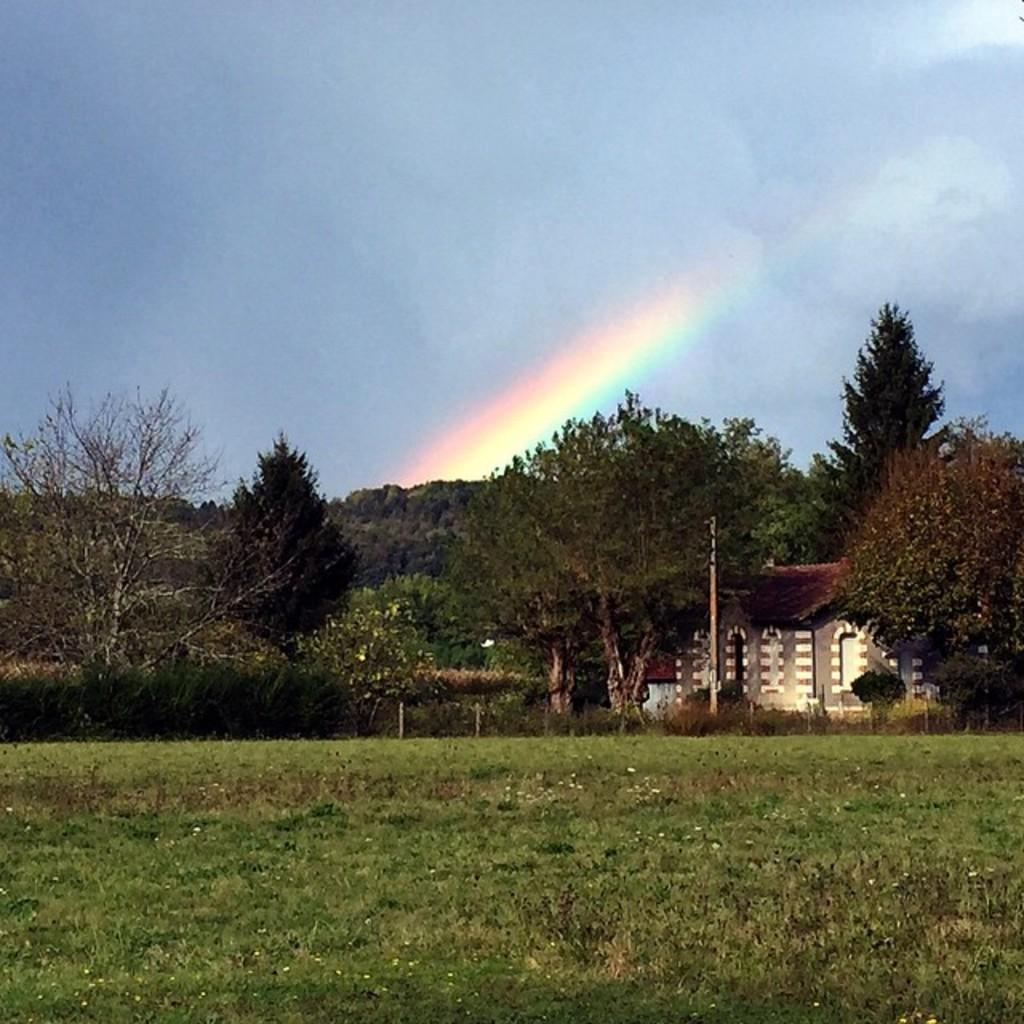What type of vegetation can be seen in the image? There are trees and plants in the image. What type of structure is present in the image? There is a building in the image. What type of terrain is visible in the image? There is grassy land in the image. What natural phenomenon can be seen in the background of the image? There is a rainbow visible in the background of the image. What else is visible in the background of the image? The sky is visible in the background of the image. Can you tell me how many teeth the person has in the image? There is no person present in the image, so it is not possible to determine the number of teeth. What type of channel is visible in the image? There is no channel present in the image; it features trees, plants, a building, grassy land, a rainbow, and the sky. 